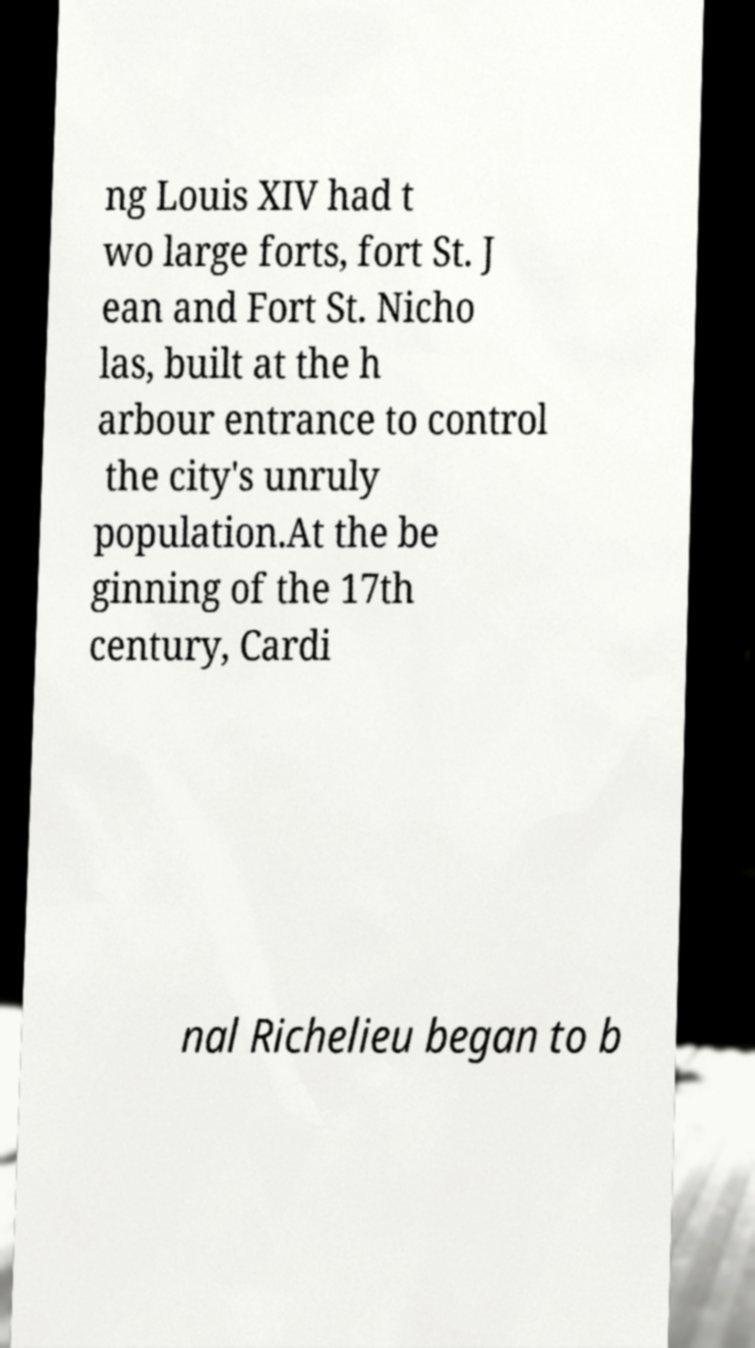For documentation purposes, I need the text within this image transcribed. Could you provide that? ng Louis XIV had t wo large forts, fort St. J ean and Fort St. Nicho las, built at the h arbour entrance to control the city's unruly population.At the be ginning of the 17th century, Cardi nal Richelieu began to b 